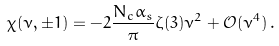<formula> <loc_0><loc_0><loc_500><loc_500>\chi ( \nu , \pm 1 ) = - 2 \frac { N _ { c } \alpha _ { s } } { \pi } \zeta ( 3 ) \nu ^ { 2 } + \mathcal { O } ( \nu ^ { 4 } ) \, .</formula> 